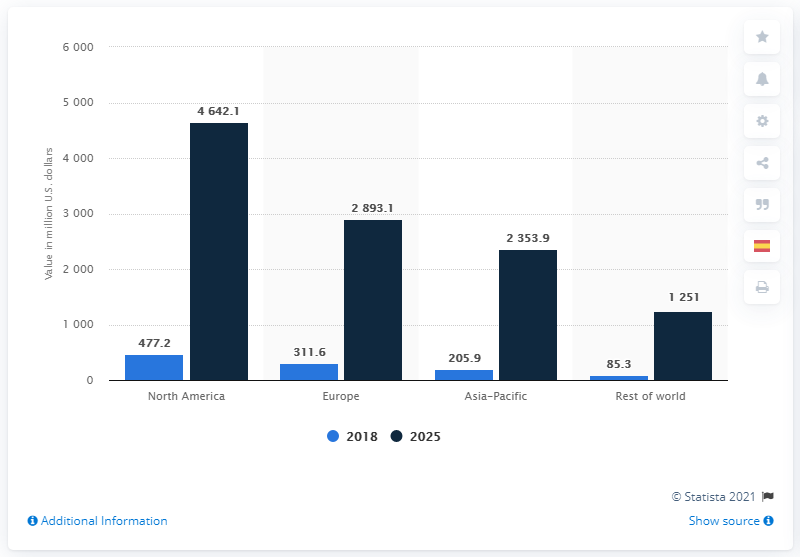Mention a couple of crucial points in this snapshot. As of 2018, the North American healthcare augmented reality (AR) and virtual reality (VR) industry had a value of 477.2. The North American healthcare augmented reality and virtual reality industry is projected to have a value of approximately 4,642.1 million US dollars by 2025. 